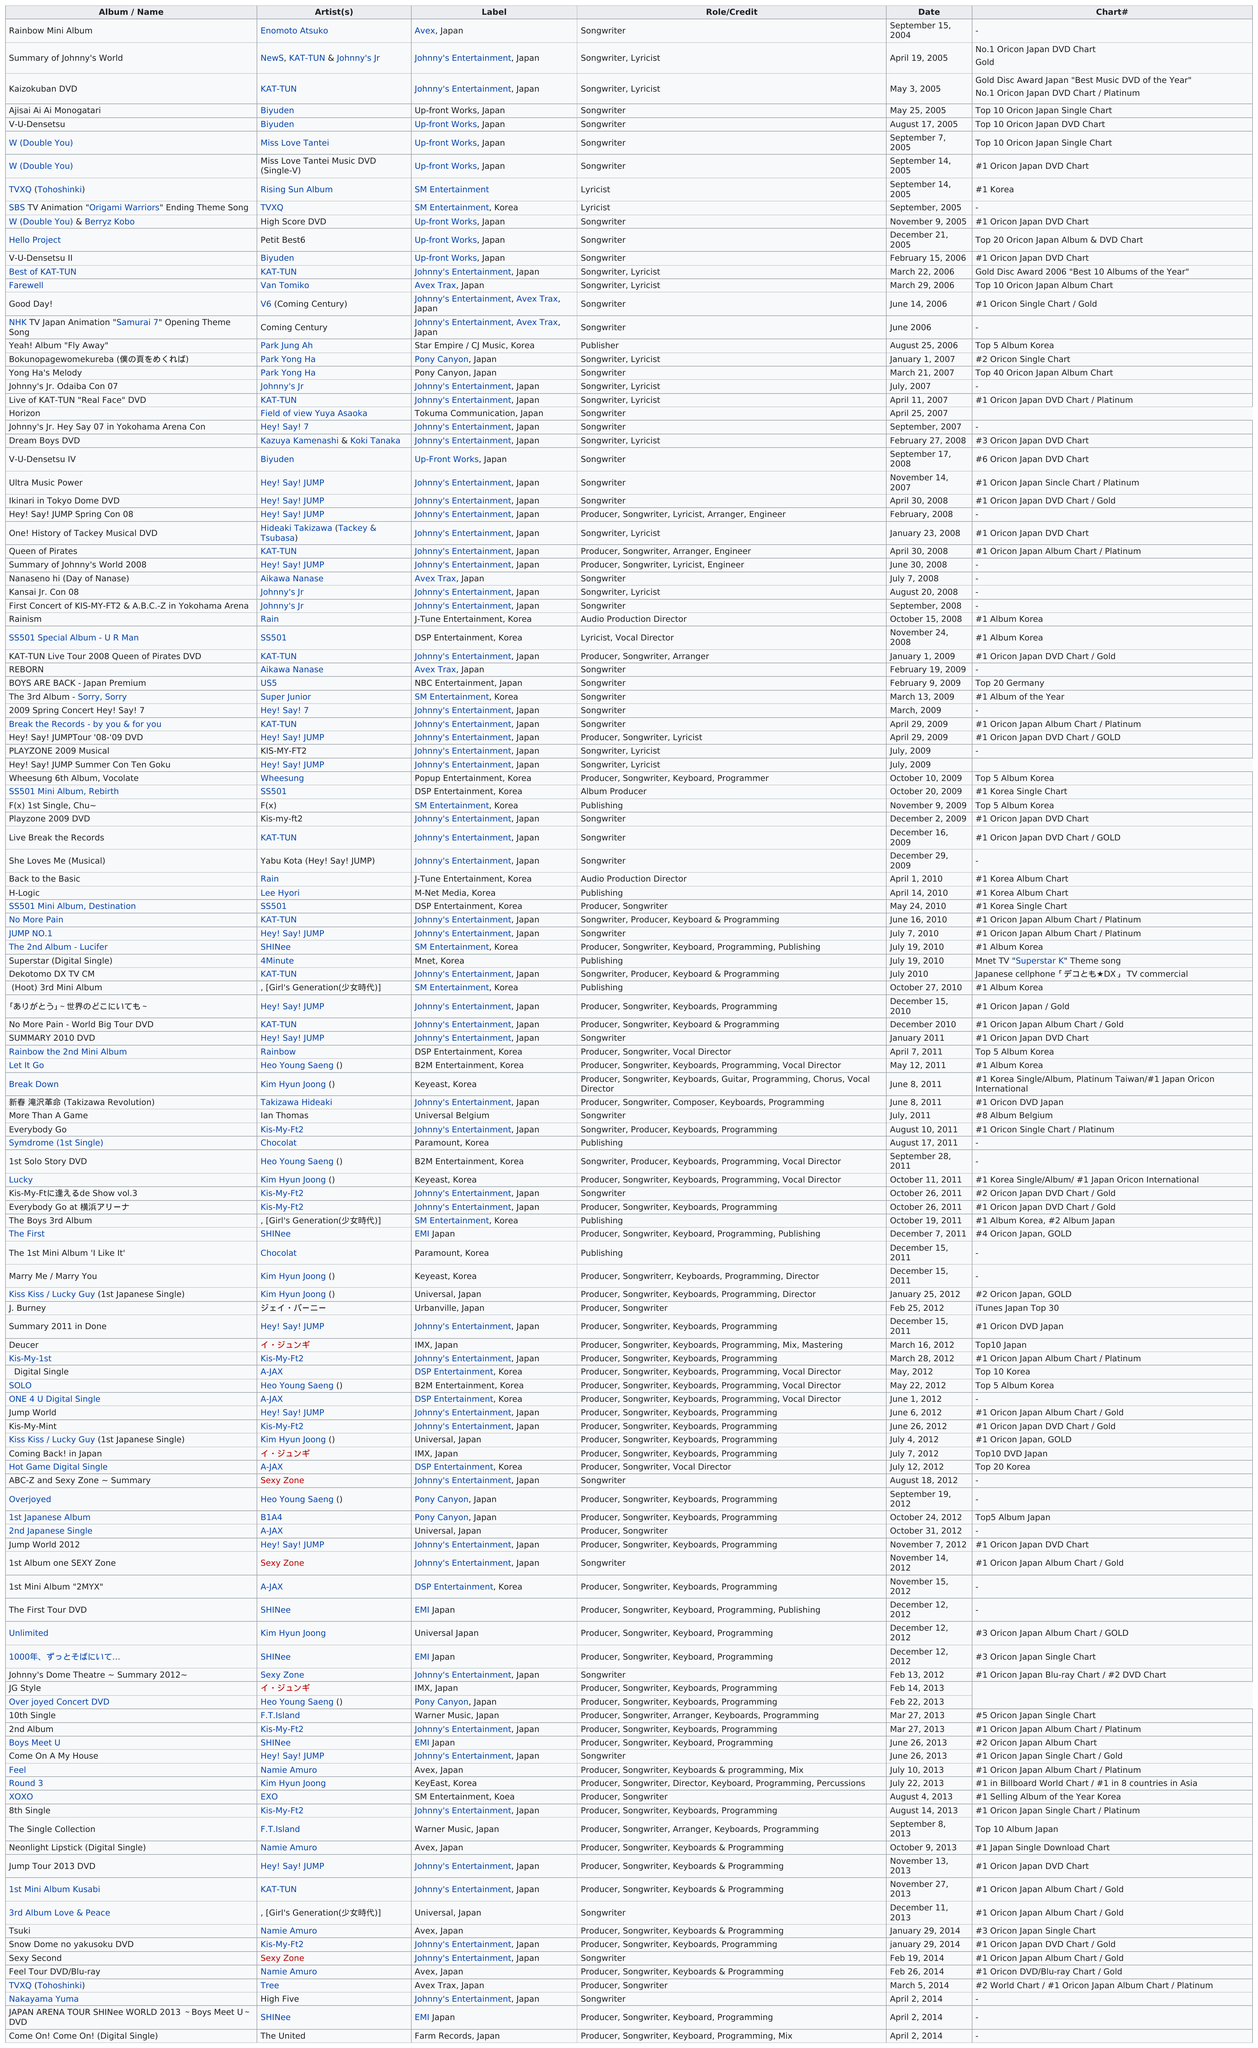Outline some significant characteristics in this image. The identity of the next artist following Artist Enomoto Atsuko, who was succeeded by NewS, KAT-TUN, and Johnny's Jr., is currently unknown. The Rainbow Mini Album was released before any other song. The top album name is 'Rainbow Mini Album'. After Pony Canyon, Japan in 2007, the artist was a part of Johnny's Entertainment, Japan. The last single released was on April 2, 2014. 